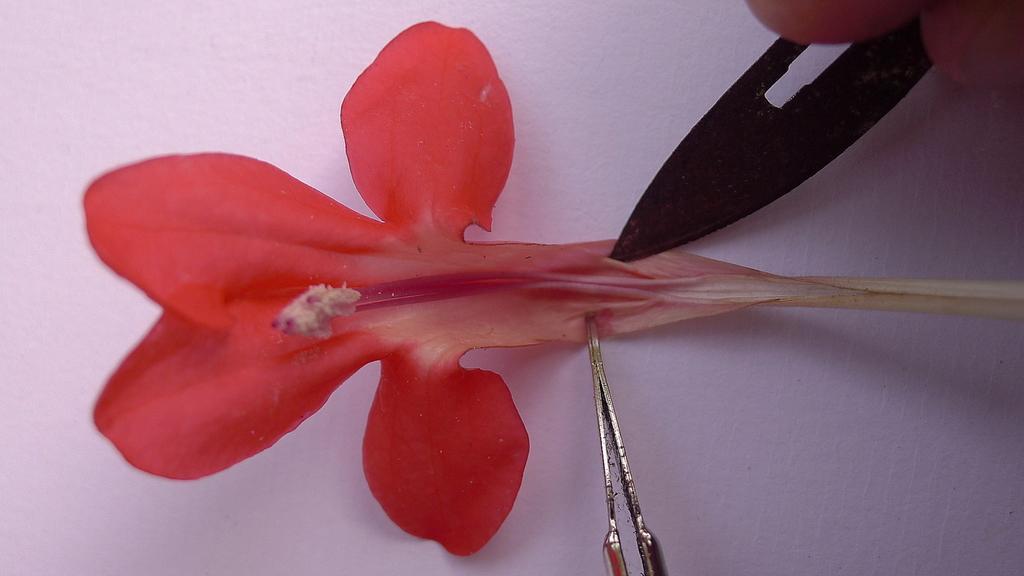Please provide a concise description of this image. In this image there are two tools on the red color flower which is on the object , and there is a person hand. 